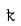Convert formula to latex. <formula><loc_0><loc_0><loc_500><loc_500>\tilde { k }</formula> 